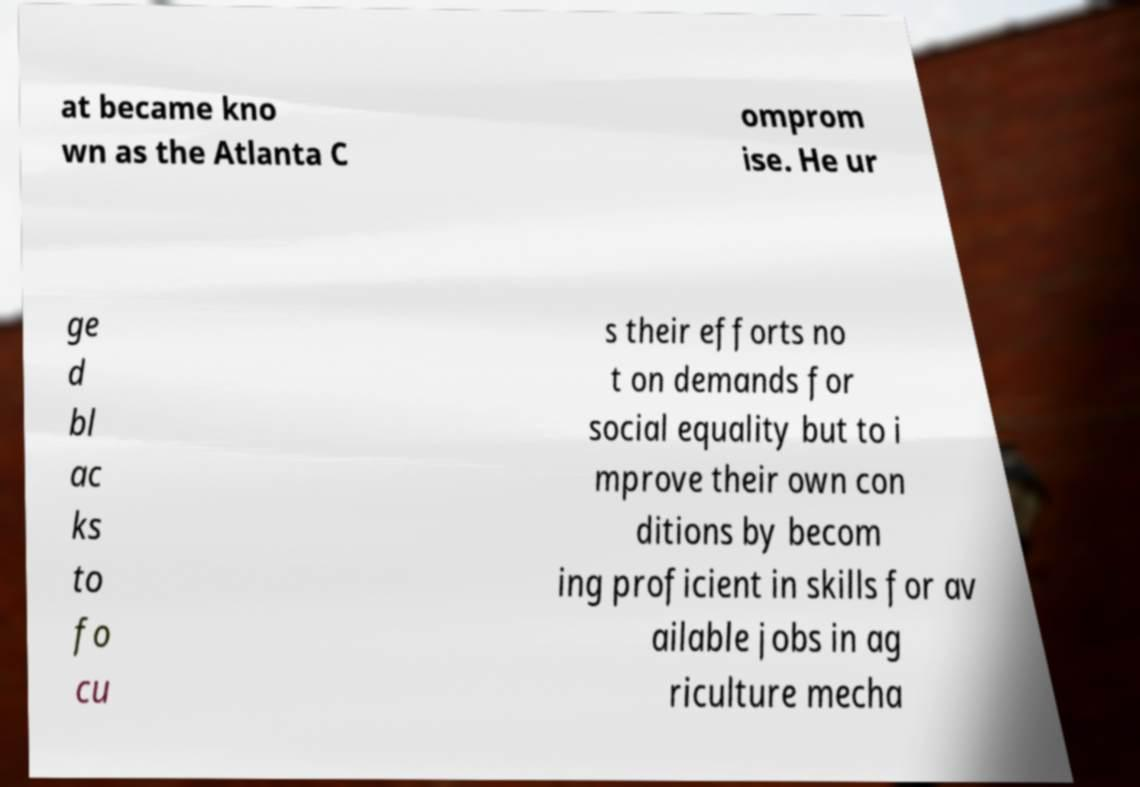Could you extract and type out the text from this image? at became kno wn as the Atlanta C omprom ise. He ur ge d bl ac ks to fo cu s their efforts no t on demands for social equality but to i mprove their own con ditions by becom ing proficient in skills for av ailable jobs in ag riculture mecha 